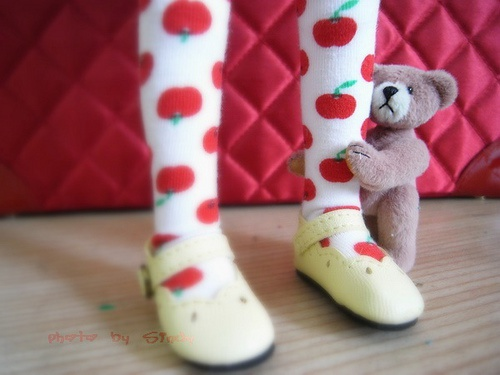Describe the objects in this image and their specific colors. I can see people in maroon, white, darkgray, brown, and tan tones, teddy bear in maroon, darkgray, and gray tones, apple in maroon, brown, and salmon tones, apple in maroon, brown, and salmon tones, and apple in maroon, brown, and salmon tones in this image. 